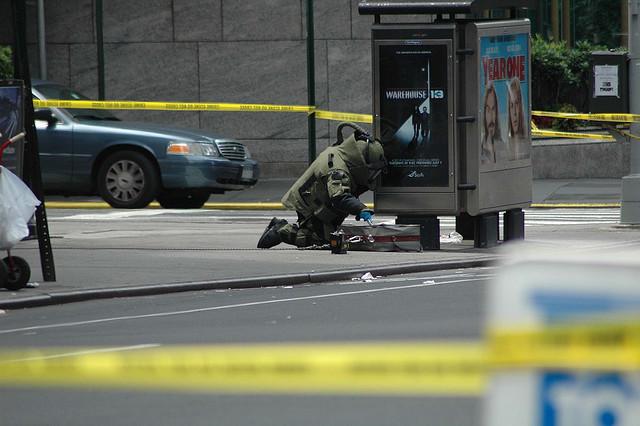What color is the tape?
Quick response, please. Yellow. What is the person doing?
Quick response, please. Collecting evidence. What is the purpose of the poster near the person's head?
Short answer required. Advertisement. 